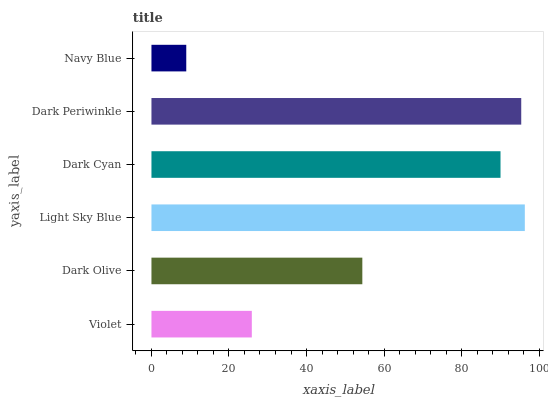Is Navy Blue the minimum?
Answer yes or no. Yes. Is Light Sky Blue the maximum?
Answer yes or no. Yes. Is Dark Olive the minimum?
Answer yes or no. No. Is Dark Olive the maximum?
Answer yes or no. No. Is Dark Olive greater than Violet?
Answer yes or no. Yes. Is Violet less than Dark Olive?
Answer yes or no. Yes. Is Violet greater than Dark Olive?
Answer yes or no. No. Is Dark Olive less than Violet?
Answer yes or no. No. Is Dark Cyan the high median?
Answer yes or no. Yes. Is Dark Olive the low median?
Answer yes or no. Yes. Is Navy Blue the high median?
Answer yes or no. No. Is Light Sky Blue the low median?
Answer yes or no. No. 